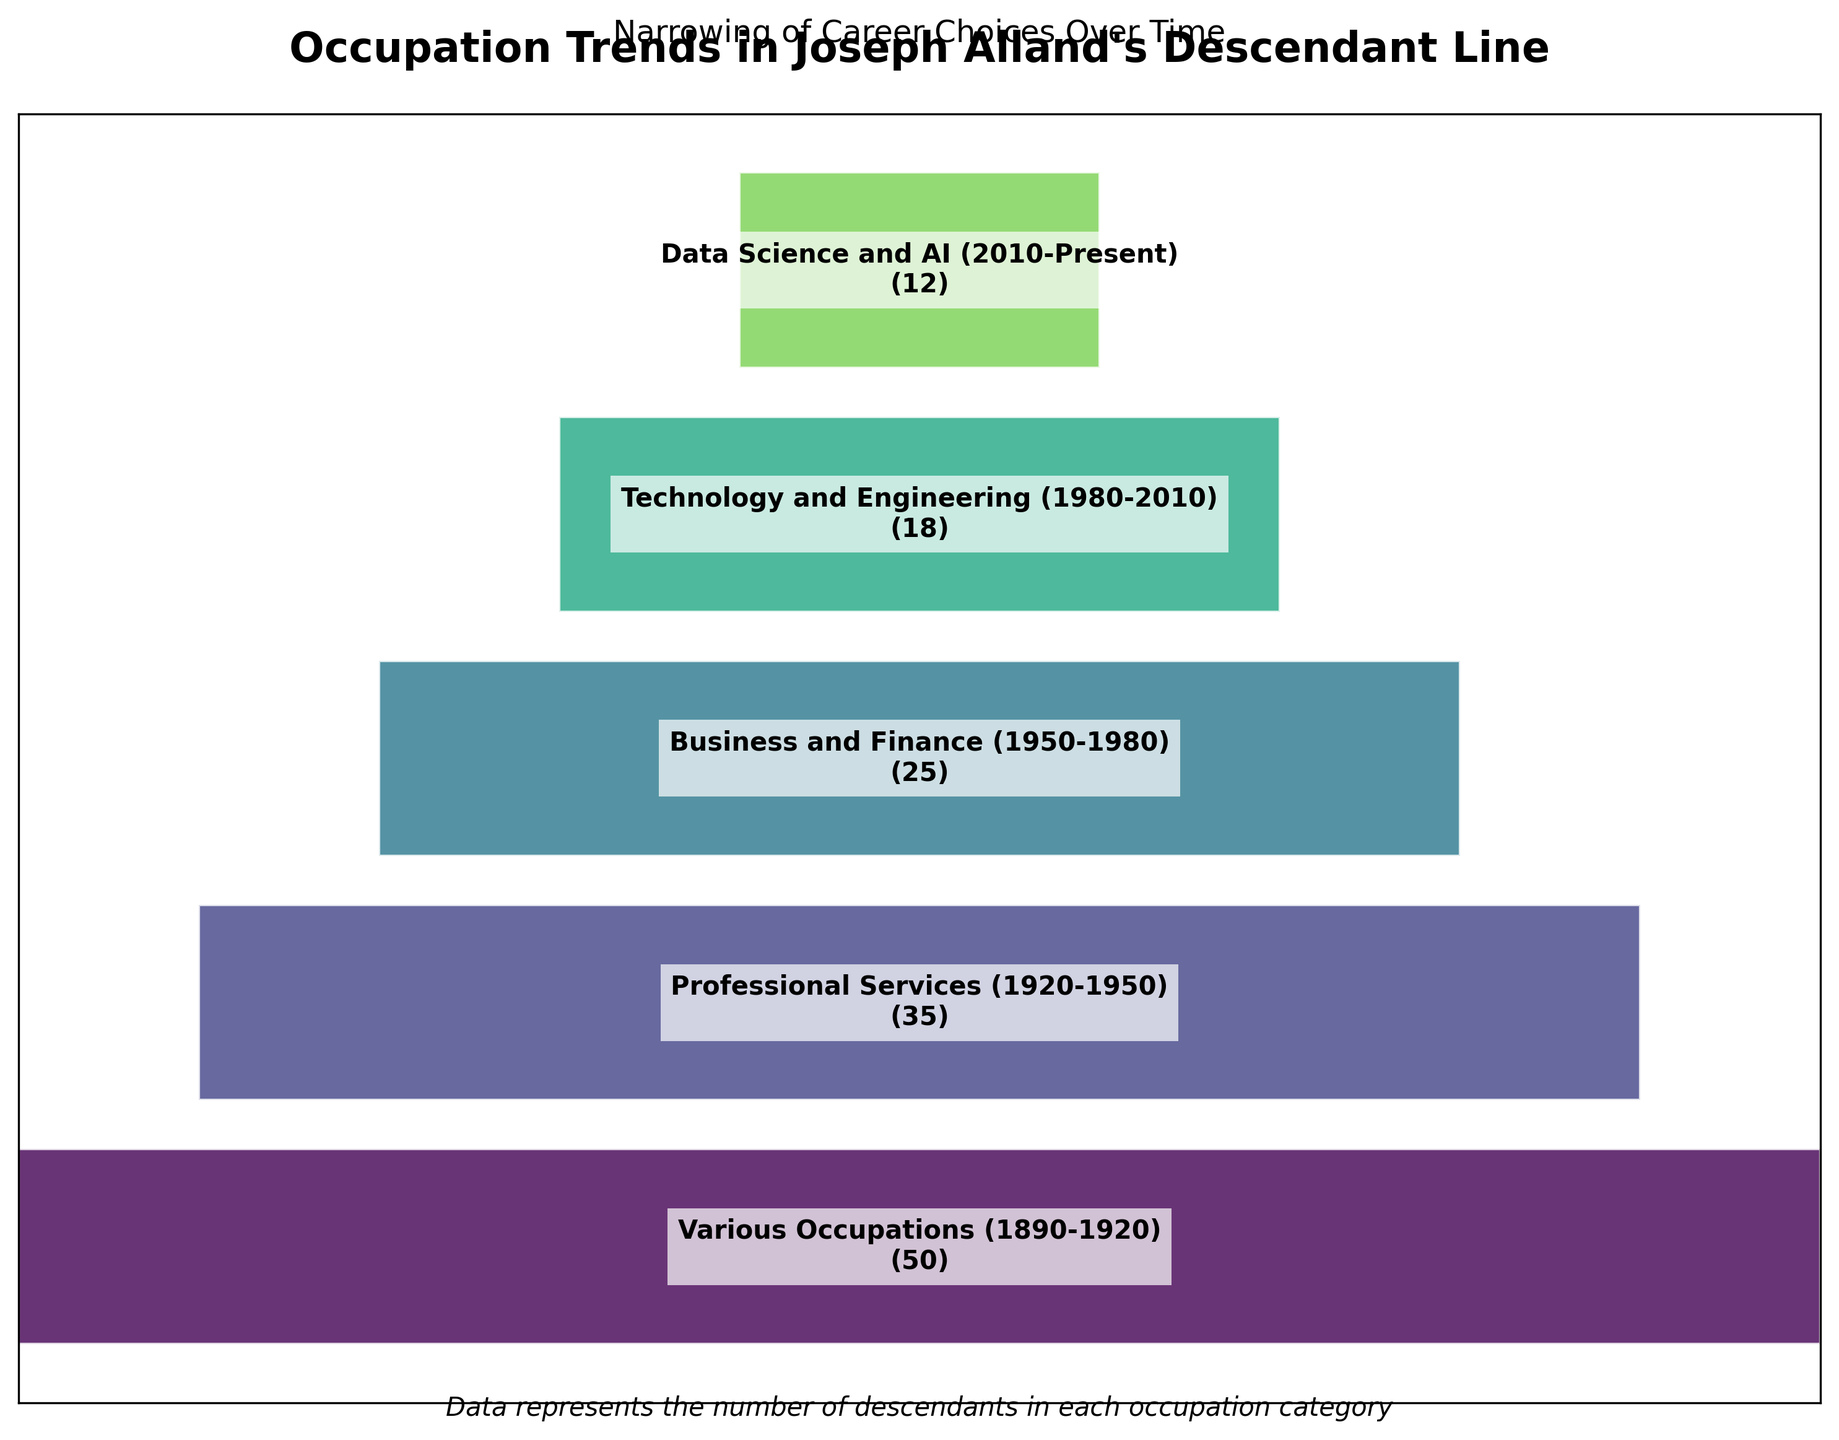Which occupation category shows the highest number of descendants? To find this, look at the funnel segment that shows the widest width at the top. The segment for "Various Occupations (1890-1920)" has the maximum width, indicating the highest number.
Answer: Various Occupations (1890-1920) How many more descendants are in "Professional Services (1920-1950)" compared to "Data Science and AI (2010-Present)"? Find the difference between the two numbers: 35 (Professional Services) - 12 (Data Science and AI) = 23.
Answer: 23 What is the trend in the number of descendants pursuing occupations from the earliest to the most recent time period? Observe the sizes of the funnel segments from top to bottom. The segments progressively narrow, indicating a decreasing number of descendants in each time period.
Answer: Decreasing trend Which two occupational categories show the smallest decrease in descendant numbers from one to the next? Look for the smallest differences between adjacent segments. The smallest difference is between "Business and Finance (1950-1980)" with 25 descendants and "Technology and Engineering (1980-2010)" with 18. The difference is 7.
Answer: Business and Finance (1950-1980) and Technology and Engineering (1980-2010) What percentage of descendants are in "Data Science and AI (2010-Present)" relative to those in "Business and Finance (1950-1980)"? Calculate the percentage by dividing the number of "Data Science and AI" descendants by the number of "Business and Finance" descendants, then multiply by 100. (12 / 25) * 100 = 48%.
Answer: 48% How has the variety of occupations changed over time? Compare the wide funnel segment at the top representing "Various Occupations (1890-1920)" to the narrower segments below. This indicates that initially, many occupations were pursued, while over time, descendants concentrated into fewer fields.
Answer: Decreased What is the ratio of descendants in "Technology and Engineering (1980-2010)" to those in "Professional Services (1920-1950)"? Divide the number of "Technology and Engineering" descendants by the number of "Professional Services" descendants: 18 / 35 = 0.514.
Answer: 0.514 From which period to which period is the largest drop in the number of descendants pursuing a certain occupation observed? Calculate the differences between adjacent periods and find the largest one. The largest drop is from "Various Occupations (1890-1920)" to "Professional Services (1920-1950)", which is 50 - 35 = 15.
Answer: 1890-1920 to 1920-1950 How many total descendants are represented in the chart? Sum up all the numbers of descendants across all categories: 50 + 35 + 25 + 18 + 12 = 140.
Answer: 140 Which occupation category represents the lowest number of descendants? Find the narrowest funnel segment at the bottom. The segment for "Data Science and AI (2010-Present)" has the smallest width, indicating the lowest number.
Answer: Data Science and AI (2010-Present) 